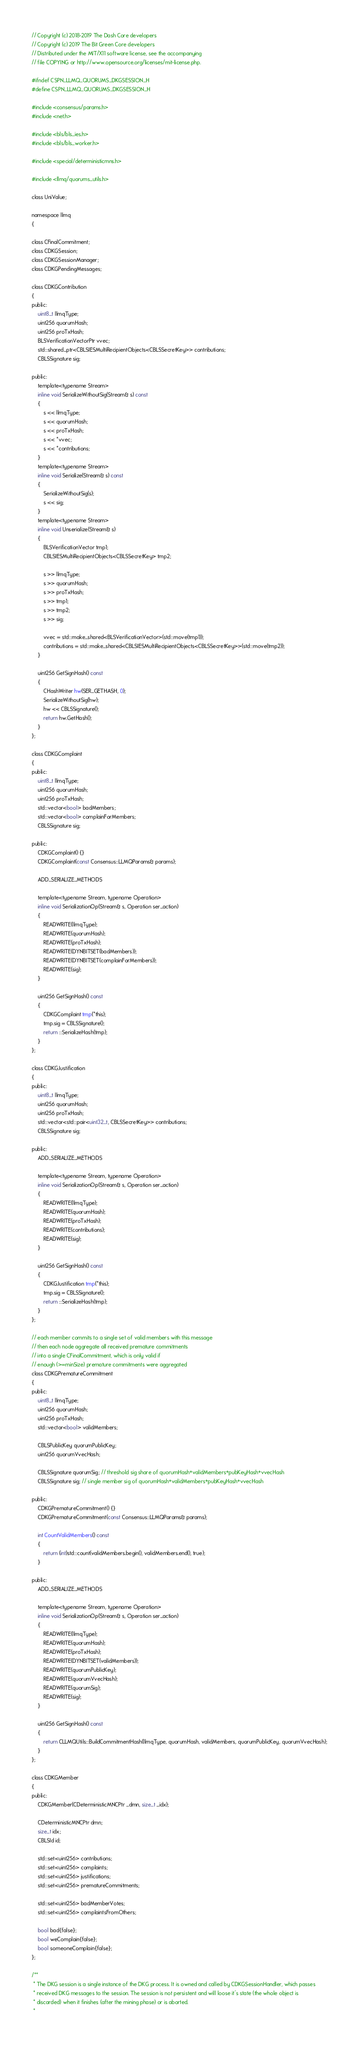<code> <loc_0><loc_0><loc_500><loc_500><_C_>// Copyright (c) 2018-2019 The Dash Core developers
// Copyright (c) 2019 The Bit Green Core developers
// Distributed under the MIT/X11 software license, see the accompanying
// file COPYING or http://www.opensource.org/licenses/mit-license.php.

#ifndef CSPN_LLMQ_QUORUMS_DKGSESSION_H
#define CSPN_LLMQ_QUORUMS_DKGSESSION_H

#include <consensus/params.h>
#include <net.h>

#include <bls/bls_ies.h>
#include <bls/bls_worker.h>

#include <special/deterministicmns.h>

#include <llmq/quorums_utils.h>

class UniValue;

namespace llmq
{

class CFinalCommitment;
class CDKGSession;
class CDKGSessionManager;
class CDKGPendingMessages;

class CDKGContribution
{
public:
    uint8_t llmqType;
    uint256 quorumHash;
    uint256 proTxHash;
    BLSVerificationVectorPtr vvec;
    std::shared_ptr<CBLSIESMultiRecipientObjects<CBLSSecretKey>> contributions;
    CBLSSignature sig;

public:
    template<typename Stream>
    inline void SerializeWithoutSig(Stream& s) const
    {
        s << llmqType;
        s << quorumHash;
        s << proTxHash;
        s << *vvec;
        s << *contributions;
    }
    template<typename Stream>
    inline void Serialize(Stream& s) const
    {
        SerializeWithoutSig(s);
        s << sig;
    }
    template<typename Stream>
    inline void Unserialize(Stream& s)
    {
        BLSVerificationVector tmp1;
        CBLSIESMultiRecipientObjects<CBLSSecretKey> tmp2;

        s >> llmqType;
        s >> quorumHash;
        s >> proTxHash;
        s >> tmp1;
        s >> tmp2;
        s >> sig;

        vvec = std::make_shared<BLSVerificationVector>(std::move(tmp1));
        contributions = std::make_shared<CBLSIESMultiRecipientObjects<CBLSSecretKey>>(std::move(tmp2));
    }

    uint256 GetSignHash() const
    {
        CHashWriter hw(SER_GETHASH, 0);
        SerializeWithoutSig(hw);
        hw << CBLSSignature();
        return hw.GetHash();
    }
};

class CDKGComplaint
{
public:
    uint8_t llmqType;
    uint256 quorumHash;
    uint256 proTxHash;
    std::vector<bool> badMembers;
    std::vector<bool> complainForMembers;
    CBLSSignature sig;

public:
    CDKGComplaint() {}
    CDKGComplaint(const Consensus::LLMQParams& params);

    ADD_SERIALIZE_METHODS

    template<typename Stream, typename Operation>
    inline void SerializationOp(Stream& s, Operation ser_action)
    {
        READWRITE(llmqType);
        READWRITE(quorumHash);
        READWRITE(proTxHash);
        READWRITE(DYNBITSET(badMembers));
        READWRITE(DYNBITSET(complainForMembers));
        READWRITE(sig);
    }

    uint256 GetSignHash() const
    {
        CDKGComplaint tmp(*this);
        tmp.sig = CBLSSignature();
        return ::SerializeHash(tmp);
    }
};

class CDKGJustification
{
public:
    uint8_t llmqType;
    uint256 quorumHash;
    uint256 proTxHash;
    std::vector<std::pair<uint32_t, CBLSSecretKey>> contributions;
    CBLSSignature sig;

public:
    ADD_SERIALIZE_METHODS

    template<typename Stream, typename Operation>
    inline void SerializationOp(Stream& s, Operation ser_action)
    {
        READWRITE(llmqType);
        READWRITE(quorumHash);
        READWRITE(proTxHash);
        READWRITE(contributions);
        READWRITE(sig);
    }

    uint256 GetSignHash() const
    {
        CDKGJustification tmp(*this);
        tmp.sig = CBLSSignature();
        return ::SerializeHash(tmp);
    }
};

// each member commits to a single set of valid members with this message
// then each node aggregate all received premature commitments
// into a single CFinalCommitment, which is only valid if
// enough (>=minSize) premature commitments were aggregated
class CDKGPrematureCommitment
{
public:
    uint8_t llmqType;
    uint256 quorumHash;
    uint256 proTxHash;
    std::vector<bool> validMembers;

    CBLSPublicKey quorumPublicKey;
    uint256 quorumVvecHash;

    CBLSSignature quorumSig; // threshold sig share of quorumHash+validMembers+pubKeyHash+vvecHash
    CBLSSignature sig; // single member sig of quorumHash+validMembers+pubKeyHash+vvecHash

public:
    CDKGPrematureCommitment() {}
    CDKGPrematureCommitment(const Consensus::LLMQParams& params);

    int CountValidMembers() const
    {
        return (int)std::count(validMembers.begin(), validMembers.end(), true);
    }

public:
    ADD_SERIALIZE_METHODS

    template<typename Stream, typename Operation>
    inline void SerializationOp(Stream& s, Operation ser_action)
    {
        READWRITE(llmqType);
        READWRITE(quorumHash);
        READWRITE(proTxHash);
        READWRITE(DYNBITSET(validMembers));
        READWRITE(quorumPublicKey);
        READWRITE(quorumVvecHash);
        READWRITE(quorumSig);
        READWRITE(sig);
    }

    uint256 GetSignHash() const
    {
        return CLLMQUtils::BuildCommitmentHash(llmqType, quorumHash, validMembers, quorumPublicKey, quorumVvecHash);
    }
};

class CDKGMember
{
public:
    CDKGMember(CDeterministicMNCPtr _dmn, size_t _idx);

    CDeterministicMNCPtr dmn;
    size_t idx;
    CBLSId id;

    std::set<uint256> contributions;
    std::set<uint256> complaints;
    std::set<uint256> justifications;
    std::set<uint256> prematureCommitments;

    std::set<uint256> badMemberVotes;
    std::set<uint256> complaintsFromOthers;

    bool bad{false};
    bool weComplain{false};
    bool someoneComplain{false};
};

/**
 * The DKG session is a single instance of the DKG process. It is owned and called by CDKGSessionHandler, which passes
 * received DKG messages to the session. The session is not persistent and will loose it's state (the whole object is
 * discarded) when it finishes (after the mining phase) or is aborted.
 *</code> 